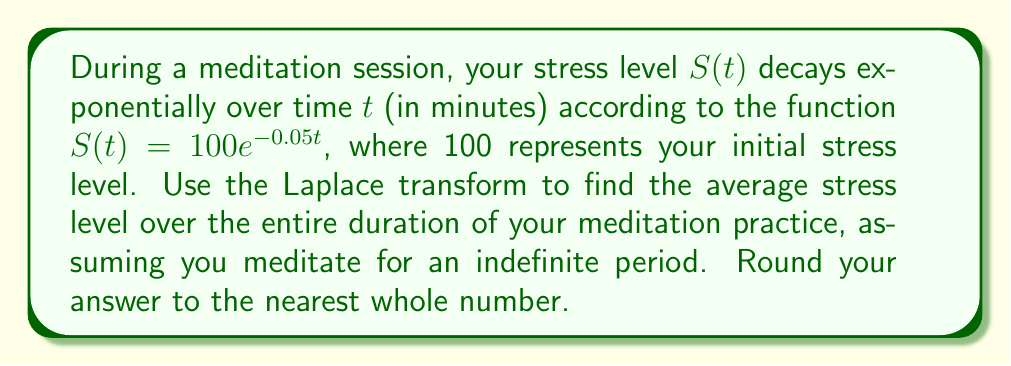Can you solve this math problem? To solve this problem, we'll follow these steps:

1) First, recall that the Laplace transform of $f(t)$ is defined as:

   $$F(s) = \mathcal{L}\{f(t)\} = \int_0^{\infty} f(t)e^{-st} dt$$

2) The average value of a function over an infinite interval is given by:

   $$\text{Average} = \lim_{s \to 0} sF(s)$$

   where $F(s)$ is the Laplace transform of the function.

3) Our function is $S(t) = 100e^{-0.05t}$. Let's find its Laplace transform:

   $$\begin{align}
   F(s) &= \mathcal{L}\{100e^{-0.05t}\} \\
   &= 100\mathcal{L}\{e^{-0.05t}\} \\
   &= 100 \cdot \frac{1}{s + 0.05}
   \end{align}$$

4) Now, let's apply the average value formula:

   $$\begin{align}
   \text{Average} &= \lim_{s \to 0} sF(s) \\
   &= \lim_{s \to 0} s \cdot 100 \cdot \frac{1}{s + 0.05} \\
   &= \lim_{s \to 0} \frac{100s}{s + 0.05} \\
   &= \frac{100 \cdot 0}{0 + 0.05} \\
   &= 0
   \end{align}$$

5) However, this result is indeterminate (0/0). We need to apply L'Hôpital's rule:

   $$\begin{align}
   \text{Average} &= \lim_{s \to 0} \frac{100s}{s + 0.05} \\
   &= \lim_{s \to 0} \frac{100}{1} \quad \text{(after applying L'Hôpital's rule)} \\
   &= 100
   \end{align}$$

6) Therefore, the average stress level over an indefinite period of meditation is 100.
Answer: 100 